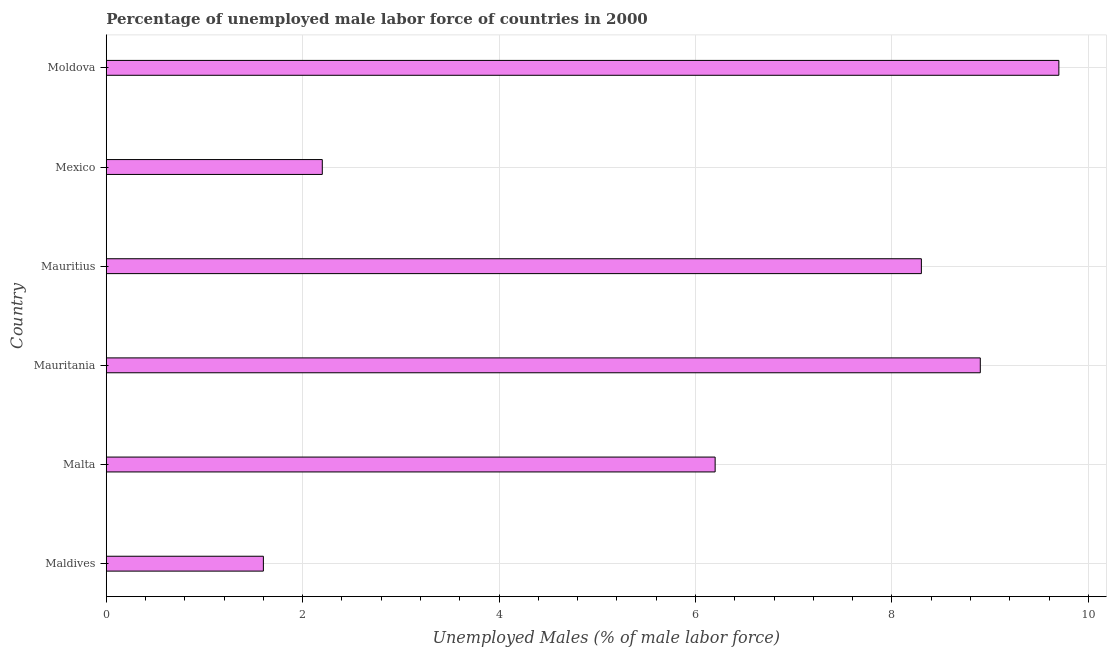Does the graph contain grids?
Your answer should be very brief. Yes. What is the title of the graph?
Ensure brevity in your answer.  Percentage of unemployed male labor force of countries in 2000. What is the label or title of the X-axis?
Provide a succinct answer. Unemployed Males (% of male labor force). What is the total unemployed male labour force in Moldova?
Provide a short and direct response. 9.7. Across all countries, what is the maximum total unemployed male labour force?
Make the answer very short. 9.7. Across all countries, what is the minimum total unemployed male labour force?
Keep it short and to the point. 1.6. In which country was the total unemployed male labour force maximum?
Keep it short and to the point. Moldova. In which country was the total unemployed male labour force minimum?
Give a very brief answer. Maldives. What is the sum of the total unemployed male labour force?
Ensure brevity in your answer.  36.9. What is the difference between the total unemployed male labour force in Mauritius and Moldova?
Keep it short and to the point. -1.4. What is the average total unemployed male labour force per country?
Give a very brief answer. 6.15. What is the median total unemployed male labour force?
Your response must be concise. 7.25. In how many countries, is the total unemployed male labour force greater than 7.2 %?
Give a very brief answer. 3. What is the ratio of the total unemployed male labour force in Mauritius to that in Mexico?
Provide a short and direct response. 3.77. Is the total unemployed male labour force in Mauritania less than that in Moldova?
Your answer should be compact. Yes. Is the difference between the total unemployed male labour force in Malta and Mauritius greater than the difference between any two countries?
Keep it short and to the point. No. What is the difference between the highest and the second highest total unemployed male labour force?
Your answer should be very brief. 0.8. Is the sum of the total unemployed male labour force in Maldives and Malta greater than the maximum total unemployed male labour force across all countries?
Offer a very short reply. No. What is the difference between the highest and the lowest total unemployed male labour force?
Offer a very short reply. 8.1. In how many countries, is the total unemployed male labour force greater than the average total unemployed male labour force taken over all countries?
Your answer should be compact. 4. How many bars are there?
Make the answer very short. 6. Are all the bars in the graph horizontal?
Your response must be concise. Yes. How many countries are there in the graph?
Your answer should be very brief. 6. What is the difference between two consecutive major ticks on the X-axis?
Keep it short and to the point. 2. What is the Unemployed Males (% of male labor force) of Maldives?
Provide a short and direct response. 1.6. What is the Unemployed Males (% of male labor force) in Malta?
Your answer should be compact. 6.2. What is the Unemployed Males (% of male labor force) in Mauritania?
Your answer should be very brief. 8.9. What is the Unemployed Males (% of male labor force) in Mauritius?
Your response must be concise. 8.3. What is the Unemployed Males (% of male labor force) of Mexico?
Your answer should be very brief. 2.2. What is the Unemployed Males (% of male labor force) in Moldova?
Keep it short and to the point. 9.7. What is the difference between the Unemployed Males (% of male labor force) in Maldives and Mexico?
Give a very brief answer. -0.6. What is the difference between the Unemployed Males (% of male labor force) in Malta and Mexico?
Your response must be concise. 4. What is the difference between the Unemployed Males (% of male labor force) in Mauritania and Mauritius?
Provide a short and direct response. 0.6. What is the difference between the Unemployed Males (% of male labor force) in Mauritania and Mexico?
Give a very brief answer. 6.7. What is the difference between the Unemployed Males (% of male labor force) in Mauritius and Mexico?
Your response must be concise. 6.1. What is the difference between the Unemployed Males (% of male labor force) in Mauritius and Moldova?
Provide a short and direct response. -1.4. What is the ratio of the Unemployed Males (% of male labor force) in Maldives to that in Malta?
Your answer should be compact. 0.26. What is the ratio of the Unemployed Males (% of male labor force) in Maldives to that in Mauritania?
Offer a terse response. 0.18. What is the ratio of the Unemployed Males (% of male labor force) in Maldives to that in Mauritius?
Provide a short and direct response. 0.19. What is the ratio of the Unemployed Males (% of male labor force) in Maldives to that in Mexico?
Keep it short and to the point. 0.73. What is the ratio of the Unemployed Males (% of male labor force) in Maldives to that in Moldova?
Keep it short and to the point. 0.17. What is the ratio of the Unemployed Males (% of male labor force) in Malta to that in Mauritania?
Provide a succinct answer. 0.7. What is the ratio of the Unemployed Males (% of male labor force) in Malta to that in Mauritius?
Ensure brevity in your answer.  0.75. What is the ratio of the Unemployed Males (% of male labor force) in Malta to that in Mexico?
Ensure brevity in your answer.  2.82. What is the ratio of the Unemployed Males (% of male labor force) in Malta to that in Moldova?
Your answer should be compact. 0.64. What is the ratio of the Unemployed Males (% of male labor force) in Mauritania to that in Mauritius?
Your response must be concise. 1.07. What is the ratio of the Unemployed Males (% of male labor force) in Mauritania to that in Mexico?
Provide a short and direct response. 4.04. What is the ratio of the Unemployed Males (% of male labor force) in Mauritania to that in Moldova?
Give a very brief answer. 0.92. What is the ratio of the Unemployed Males (% of male labor force) in Mauritius to that in Mexico?
Offer a very short reply. 3.77. What is the ratio of the Unemployed Males (% of male labor force) in Mauritius to that in Moldova?
Provide a short and direct response. 0.86. What is the ratio of the Unemployed Males (% of male labor force) in Mexico to that in Moldova?
Provide a succinct answer. 0.23. 